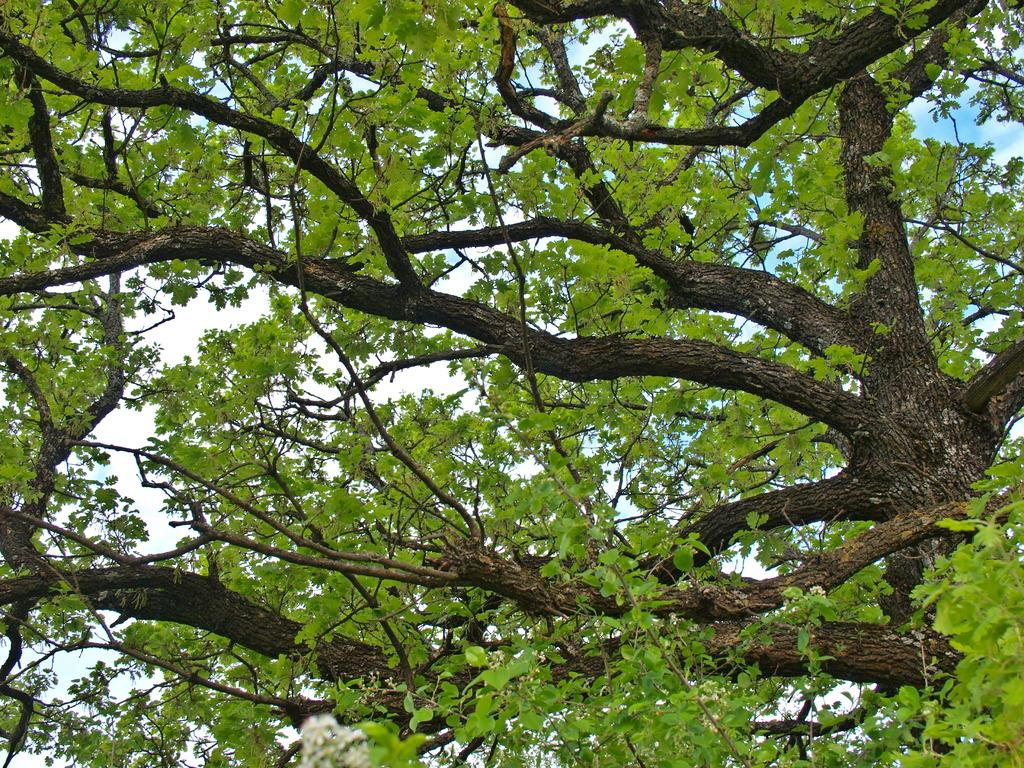What is the main subject of the image? The main subject of the image is a tree. Can you describe the colors of the tree? The tree has green and brown colors. What can be seen in the background of the image? The sky is visible in the background through gaps in the trees. What type of drum can be seen hanging from the tree in the image? There is no drum present in the image; it only features a tree with green and brown colors and a visible sky in the background. 